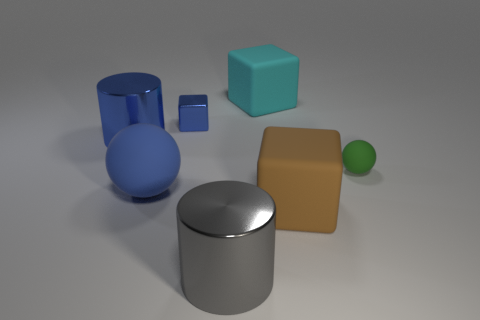How many tiny blocks are behind the tiny thing that is to the right of the rubber cube that is on the right side of the big cyan rubber block?
Ensure brevity in your answer.  1. Does the blue rubber ball have the same size as the blue object behind the large blue cylinder?
Offer a very short reply. No. How many tiny metal spheres are there?
Offer a very short reply. 0. There is a thing left of the large blue matte sphere; is it the same size as the rubber sphere right of the small blue cube?
Make the answer very short. No. What color is the other rubber object that is the same shape as the brown object?
Your response must be concise. Cyan. Does the big blue rubber object have the same shape as the green rubber thing?
Ensure brevity in your answer.  Yes. What size is the metal thing that is the same shape as the large cyan rubber object?
Give a very brief answer. Small. What number of big blue cylinders are made of the same material as the gray thing?
Give a very brief answer. 1. How many objects are blue rubber objects or tiny gray balls?
Offer a very short reply. 1. There is a big rubber cube that is in front of the big cyan block; is there a metal cylinder that is in front of it?
Your response must be concise. Yes. 